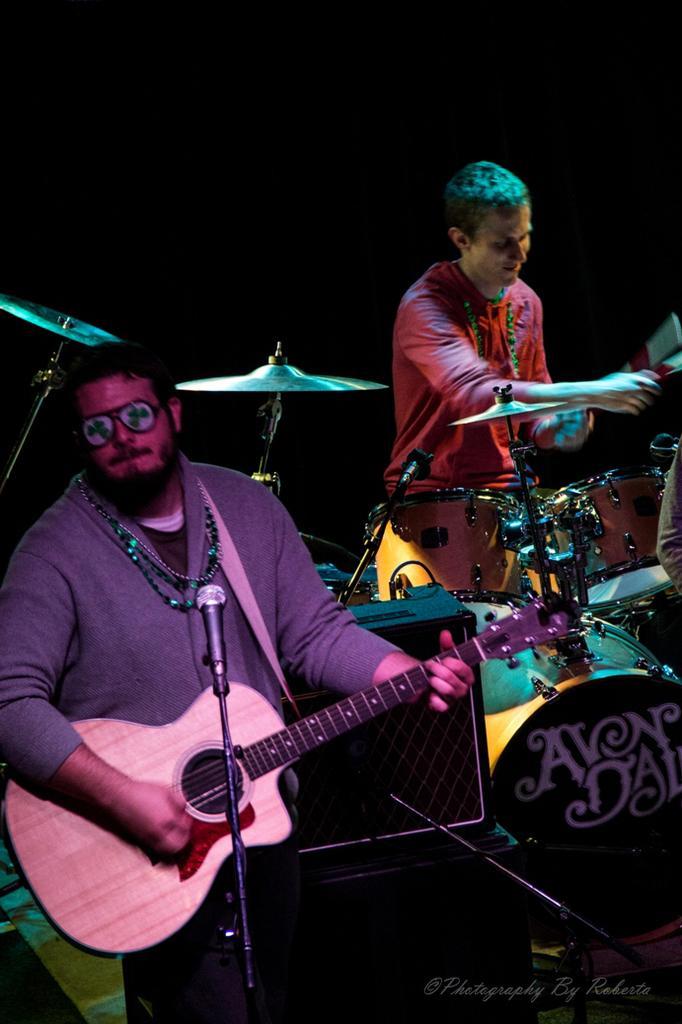Can you describe this image briefly? Front this man wore jacket, goggles and playing guitar in-front of mic. Backside of this person another person is playing this musical instruments with sticks. Here we can able to see speakers. 